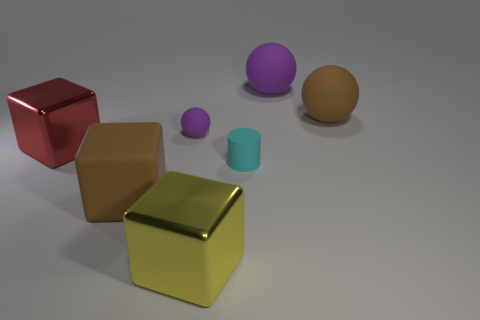There is a brown ball that is the same size as the yellow metal thing; what material is it? rubber 